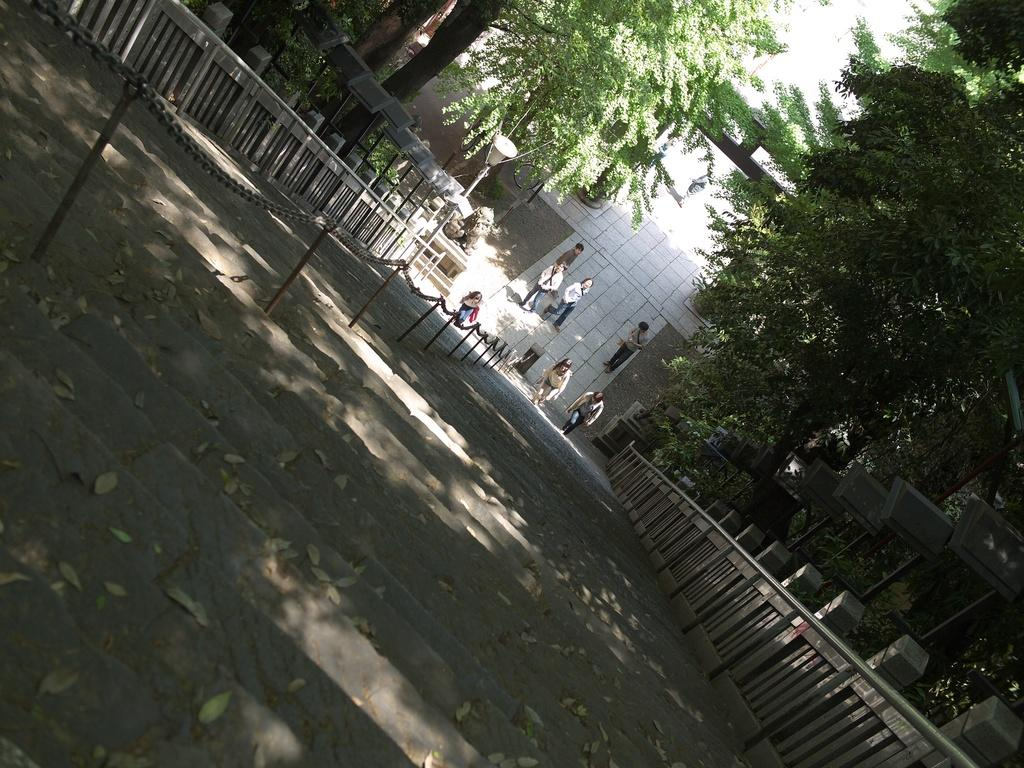What can be seen on the ground in the image? There are people on the ground in the image. What type of natural elements are present in the image? There are trees in the image. Are there any architectural features visible in the image? Yes, there are steps in the image. What is used to enclose or separate areas in the image? There is a fence in the image. What other objects can be seen in the image besides the people, trees, steps, and fence? There are other objects present in the image. What type of cord is being used by the goose in the image? There is no goose present in the image, and therefore no cord being used by a goose. 